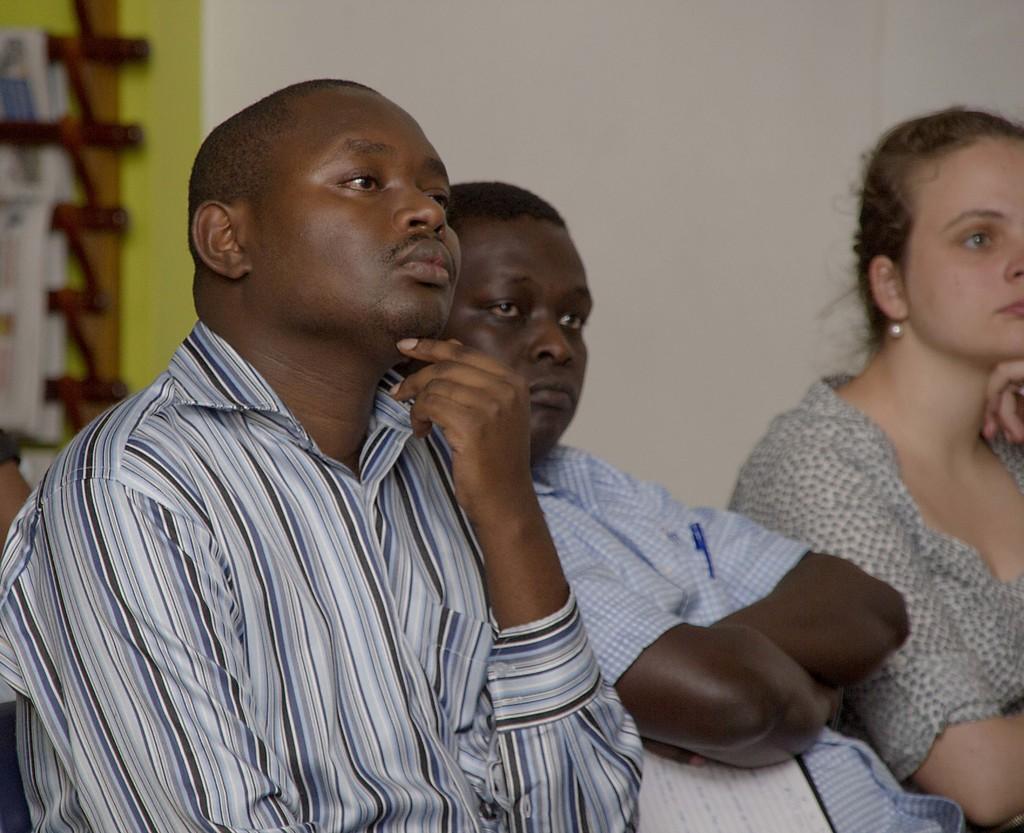How would you summarize this image in a sentence or two? In the picture we can see two men and one woman are sitting and watching something keen and behind them, we can see a wall and beside it we can see a rack with some papers in it. 